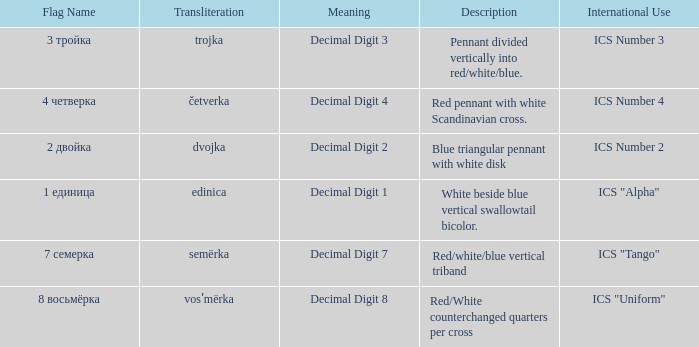What is the international use of the 1 единица flag? ICS "Alpha". 